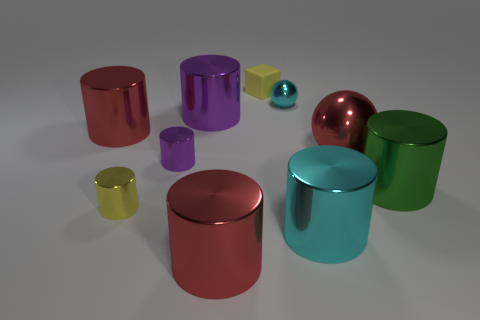What is the tiny thing that is both behind the yellow cylinder and to the left of the yellow cube made of?
Your answer should be compact. Metal. Do the cyan cylinder and the yellow metal thing have the same size?
Your response must be concise. No. There is a purple metallic object in front of the big red thing that is behind the big red shiny sphere; what size is it?
Your response must be concise. Small. How many red metallic things are both behind the big green cylinder and in front of the green cylinder?
Keep it short and to the point. 0. There is a metallic cylinder to the right of the red metallic thing on the right side of the big cyan cylinder; are there any large red balls that are in front of it?
Offer a terse response. No. The yellow thing that is the same size as the yellow metallic cylinder is what shape?
Give a very brief answer. Cube. Is there a large metallic cylinder that has the same color as the small rubber object?
Provide a short and direct response. No. Is the shape of the large purple thing the same as the tiny cyan metal thing?
Your answer should be very brief. No. How many small objects are purple objects or red matte cylinders?
Your response must be concise. 1. There is a large ball that is the same material as the cyan cylinder; what is its color?
Provide a short and direct response. Red. 